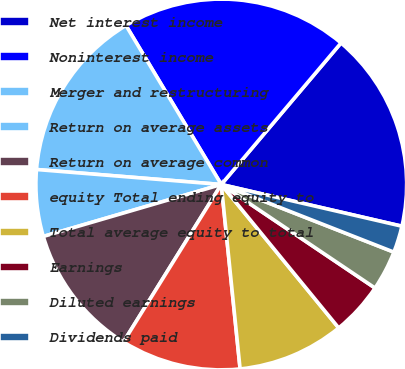Convert chart to OTSL. <chart><loc_0><loc_0><loc_500><loc_500><pie_chart><fcel>Net interest income<fcel>Noninterest income<fcel>Merger and restructuring<fcel>Return on average assets<fcel>Return on average common<fcel>equity Total ending equity to<fcel>Total average equity to total<fcel>Earnings<fcel>Diluted earnings<fcel>Dividends paid<nl><fcel>17.44%<fcel>19.77%<fcel>15.12%<fcel>5.81%<fcel>11.63%<fcel>10.47%<fcel>9.3%<fcel>4.65%<fcel>3.49%<fcel>2.33%<nl></chart> 